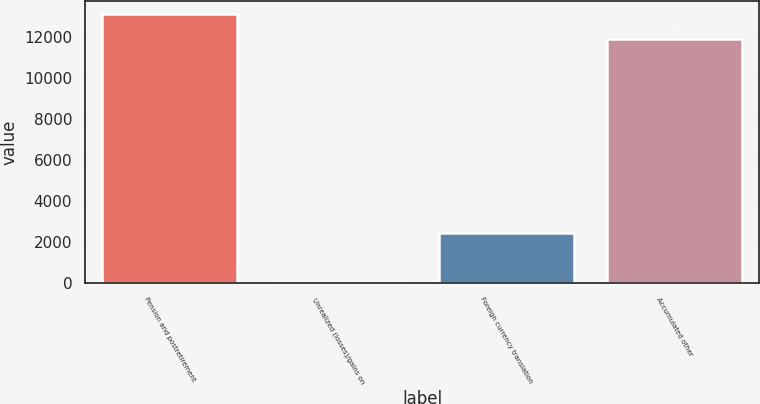<chart> <loc_0><loc_0><loc_500><loc_500><bar_chart><fcel>Pension and postretirement<fcel>Unrealized (losses)/gains on<fcel>Foreign currency translation<fcel>Accumulated other<nl><fcel>13091.8<fcel>6<fcel>2435.6<fcel>11877<nl></chart> 